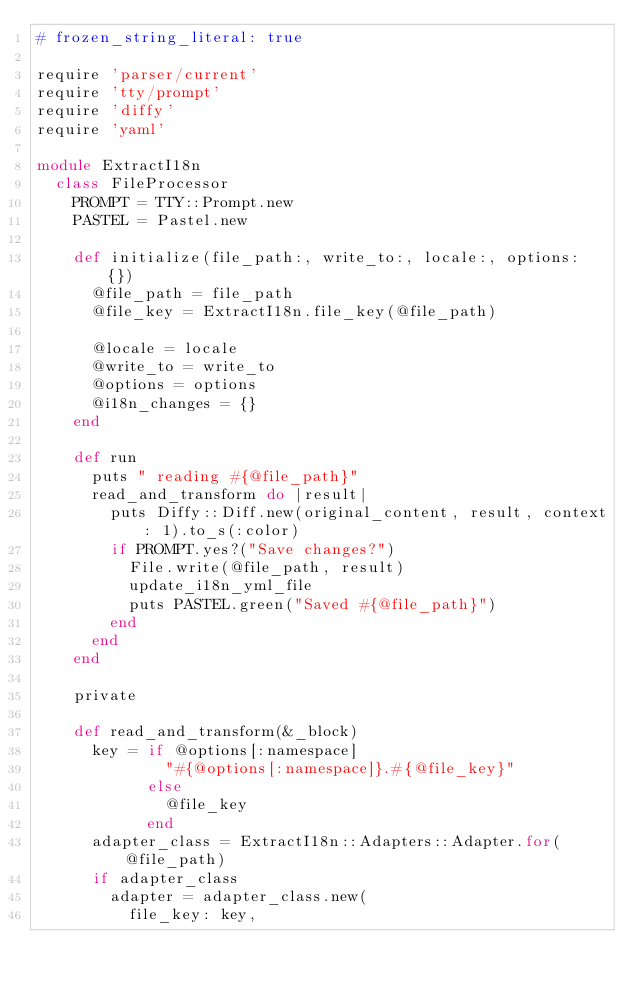Convert code to text. <code><loc_0><loc_0><loc_500><loc_500><_Ruby_># frozen_string_literal: true

require 'parser/current'
require 'tty/prompt'
require 'diffy'
require 'yaml'

module ExtractI18n
  class FileProcessor
    PROMPT = TTY::Prompt.new
    PASTEL = Pastel.new

    def initialize(file_path:, write_to:, locale:, options: {})
      @file_path = file_path
      @file_key = ExtractI18n.file_key(@file_path)

      @locale = locale
      @write_to = write_to
      @options = options
      @i18n_changes = {}
    end

    def run
      puts " reading #{@file_path}"
      read_and_transform do |result|
        puts Diffy::Diff.new(original_content, result, context: 1).to_s(:color)
        if PROMPT.yes?("Save changes?")
          File.write(@file_path, result)
          update_i18n_yml_file
          puts PASTEL.green("Saved #{@file_path}")
        end
      end
    end

    private

    def read_and_transform(&_block)
      key = if @options[:namespace]
              "#{@options[:namespace]}.#{@file_key}"
            else
              @file_key
            end
      adapter_class = ExtractI18n::Adapters::Adapter.for(@file_path)
      if adapter_class
        adapter = adapter_class.new(
          file_key: key,</code> 